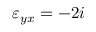Convert formula to latex. <formula><loc_0><loc_0><loc_500><loc_500>\varepsilon _ { y x } = - 2 i</formula> 